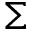<formula> <loc_0><loc_0><loc_500><loc_500>\Sigma</formula> 